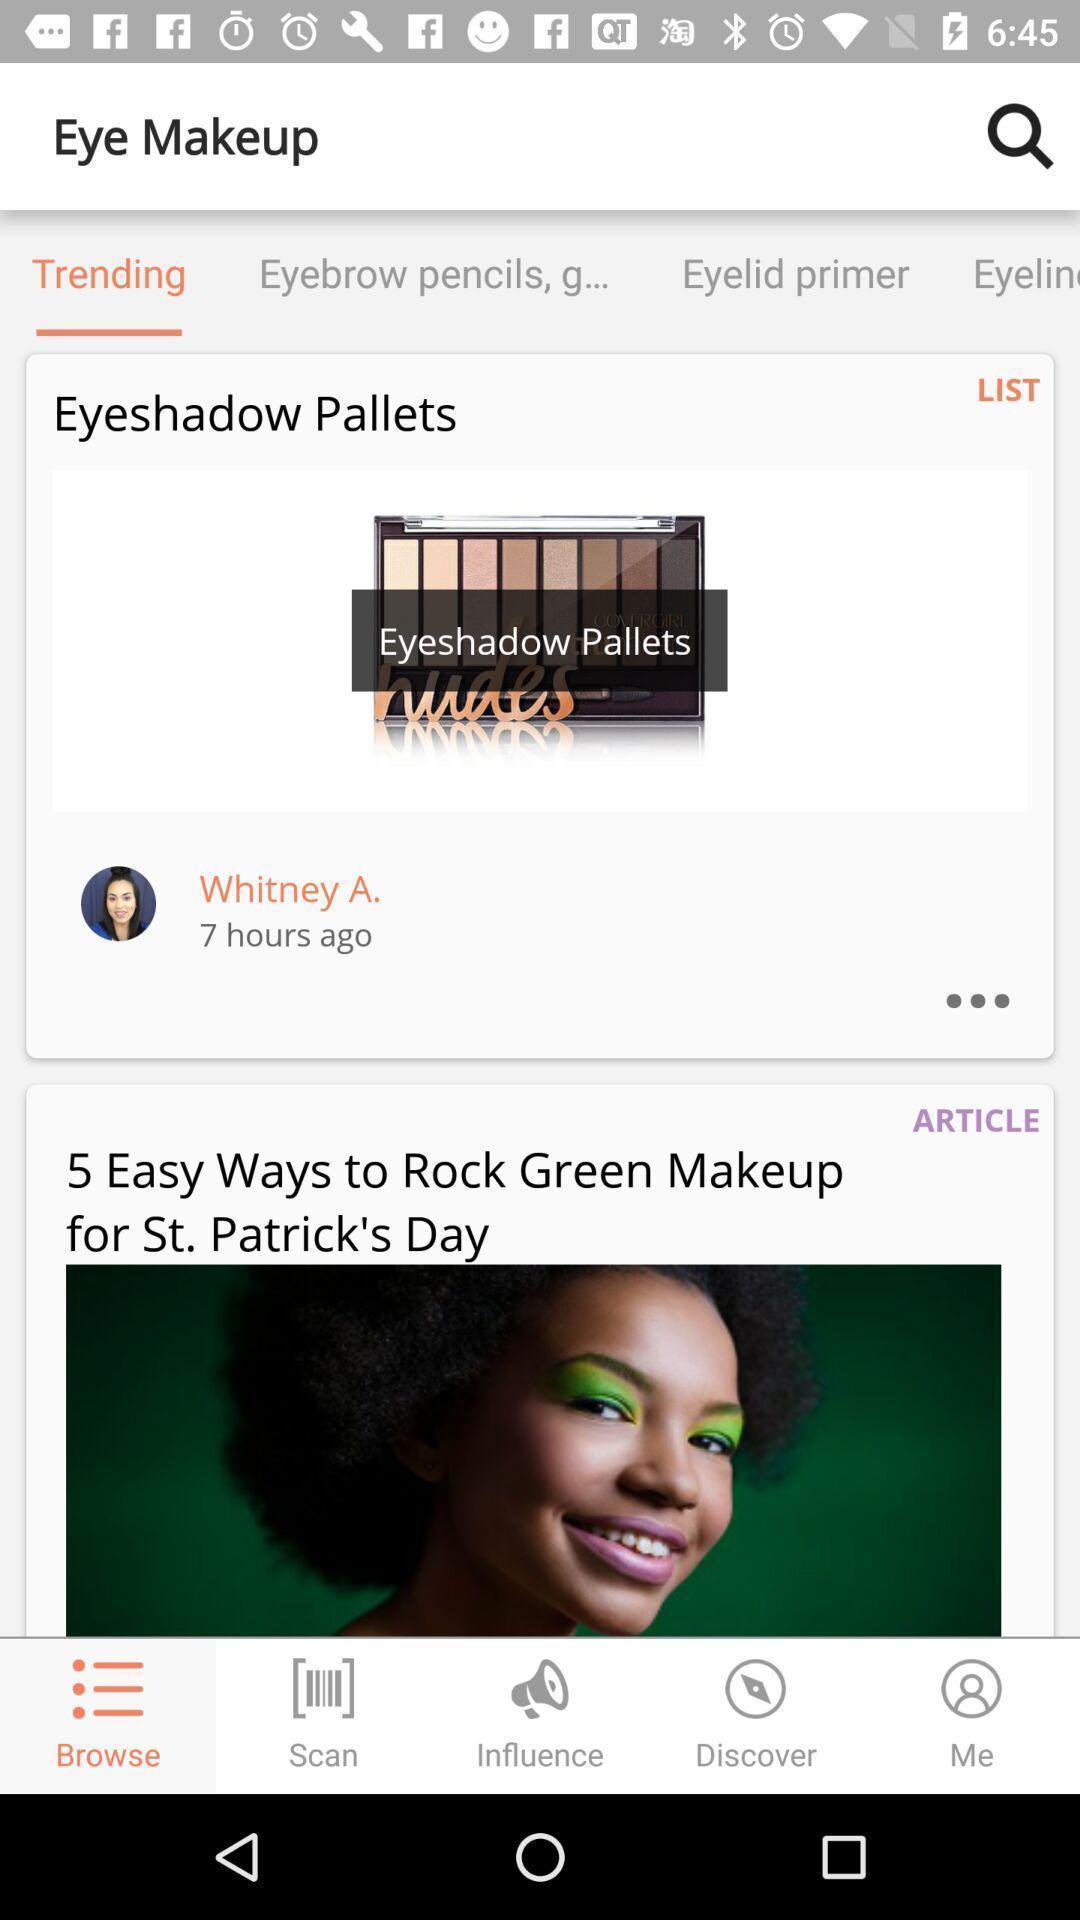What details can you identify in this image? Trending products on a beauty app. 